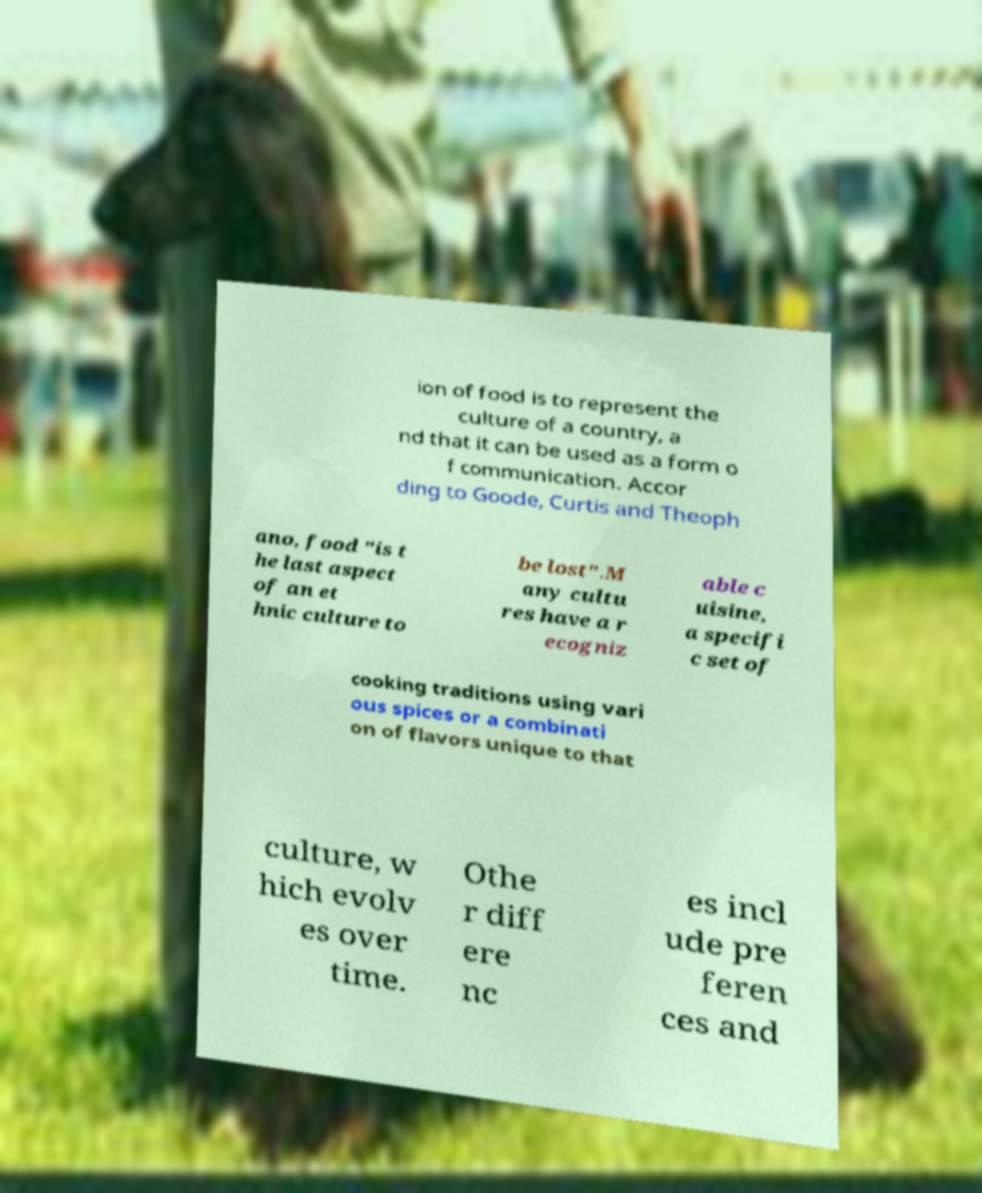Could you extract and type out the text from this image? ion of food is to represent the culture of a country, a nd that it can be used as a form o f communication. Accor ding to Goode, Curtis and Theoph ano, food "is t he last aspect of an et hnic culture to be lost".M any cultu res have a r ecogniz able c uisine, a specifi c set of cooking traditions using vari ous spices or a combinati on of flavors unique to that culture, w hich evolv es over time. Othe r diff ere nc es incl ude pre feren ces and 